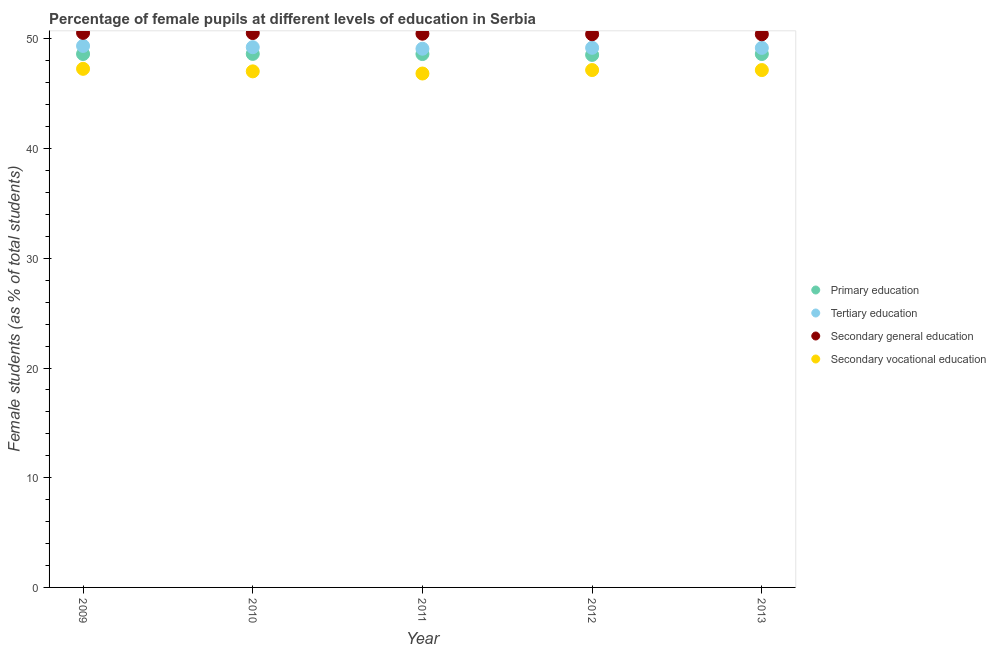Is the number of dotlines equal to the number of legend labels?
Your response must be concise. Yes. What is the percentage of female students in secondary education in 2013?
Make the answer very short. 50.43. Across all years, what is the maximum percentage of female students in tertiary education?
Provide a succinct answer. 49.36. Across all years, what is the minimum percentage of female students in secondary vocational education?
Give a very brief answer. 46.85. In which year was the percentage of female students in primary education maximum?
Ensure brevity in your answer.  2010. What is the total percentage of female students in tertiary education in the graph?
Make the answer very short. 246.1. What is the difference between the percentage of female students in tertiary education in 2009 and that in 2012?
Your answer should be compact. 0.17. What is the difference between the percentage of female students in tertiary education in 2011 and the percentage of female students in primary education in 2010?
Offer a terse response. 0.47. What is the average percentage of female students in secondary vocational education per year?
Offer a terse response. 47.1. In the year 2011, what is the difference between the percentage of female students in secondary vocational education and percentage of female students in secondary education?
Offer a terse response. -3.63. In how many years, is the percentage of female students in secondary education greater than 44 %?
Offer a very short reply. 5. What is the ratio of the percentage of female students in secondary vocational education in 2011 to that in 2013?
Provide a succinct answer. 0.99. Is the difference between the percentage of female students in primary education in 2010 and 2011 greater than the difference between the percentage of female students in secondary education in 2010 and 2011?
Give a very brief answer. No. What is the difference between the highest and the second highest percentage of female students in tertiary education?
Provide a short and direct response. 0.12. What is the difference between the highest and the lowest percentage of female students in secondary education?
Provide a succinct answer. 0.13. Is the sum of the percentage of female students in secondary vocational education in 2011 and 2012 greater than the maximum percentage of female students in secondary education across all years?
Make the answer very short. Yes. Is it the case that in every year, the sum of the percentage of female students in secondary education and percentage of female students in tertiary education is greater than the sum of percentage of female students in secondary vocational education and percentage of female students in primary education?
Give a very brief answer. No. Is it the case that in every year, the sum of the percentage of female students in primary education and percentage of female students in tertiary education is greater than the percentage of female students in secondary education?
Offer a very short reply. Yes. How many dotlines are there?
Your answer should be very brief. 4. How many years are there in the graph?
Your answer should be very brief. 5. What is the difference between two consecutive major ticks on the Y-axis?
Your answer should be compact. 10. Does the graph contain grids?
Provide a succinct answer. No. Where does the legend appear in the graph?
Make the answer very short. Center right. How many legend labels are there?
Your answer should be very brief. 4. What is the title of the graph?
Keep it short and to the point. Percentage of female pupils at different levels of education in Serbia. Does "Korea" appear as one of the legend labels in the graph?
Your response must be concise. No. What is the label or title of the Y-axis?
Provide a short and direct response. Female students (as % of total students). What is the Female students (as % of total students) of Primary education in 2009?
Give a very brief answer. 48.63. What is the Female students (as % of total students) in Tertiary education in 2009?
Keep it short and to the point. 49.36. What is the Female students (as % of total students) in Secondary general education in 2009?
Your answer should be compact. 50.56. What is the Female students (as % of total students) of Secondary vocational education in 2009?
Offer a very short reply. 47.28. What is the Female students (as % of total students) of Primary education in 2010?
Provide a succinct answer. 48.64. What is the Female students (as % of total students) in Tertiary education in 2010?
Keep it short and to the point. 49.25. What is the Female students (as % of total students) in Secondary general education in 2010?
Make the answer very short. 50.54. What is the Female students (as % of total students) in Secondary vocational education in 2010?
Provide a succinct answer. 47.05. What is the Female students (as % of total students) in Primary education in 2011?
Make the answer very short. 48.62. What is the Female students (as % of total students) in Tertiary education in 2011?
Your answer should be very brief. 49.11. What is the Female students (as % of total students) of Secondary general education in 2011?
Your response must be concise. 50.48. What is the Female students (as % of total students) in Secondary vocational education in 2011?
Keep it short and to the point. 46.85. What is the Female students (as % of total students) in Primary education in 2012?
Offer a terse response. 48.55. What is the Female students (as % of total students) in Tertiary education in 2012?
Give a very brief answer. 49.19. What is the Female students (as % of total students) of Secondary general education in 2012?
Make the answer very short. 50.43. What is the Female students (as % of total students) of Secondary vocational education in 2012?
Keep it short and to the point. 47.17. What is the Female students (as % of total students) of Primary education in 2013?
Make the answer very short. 48.63. What is the Female students (as % of total students) of Tertiary education in 2013?
Offer a very short reply. 49.18. What is the Female students (as % of total students) of Secondary general education in 2013?
Provide a short and direct response. 50.43. What is the Female students (as % of total students) of Secondary vocational education in 2013?
Provide a short and direct response. 47.16. Across all years, what is the maximum Female students (as % of total students) of Primary education?
Your response must be concise. 48.64. Across all years, what is the maximum Female students (as % of total students) in Tertiary education?
Provide a short and direct response. 49.36. Across all years, what is the maximum Female students (as % of total students) in Secondary general education?
Provide a succinct answer. 50.56. Across all years, what is the maximum Female students (as % of total students) in Secondary vocational education?
Your answer should be very brief. 47.28. Across all years, what is the minimum Female students (as % of total students) of Primary education?
Your answer should be very brief. 48.55. Across all years, what is the minimum Female students (as % of total students) of Tertiary education?
Your answer should be very brief. 49.11. Across all years, what is the minimum Female students (as % of total students) of Secondary general education?
Ensure brevity in your answer.  50.43. Across all years, what is the minimum Female students (as % of total students) in Secondary vocational education?
Your answer should be very brief. 46.85. What is the total Female students (as % of total students) in Primary education in the graph?
Offer a terse response. 243.06. What is the total Female students (as % of total students) of Tertiary education in the graph?
Make the answer very short. 246.1. What is the total Female students (as % of total students) of Secondary general education in the graph?
Your answer should be very brief. 252.43. What is the total Female students (as % of total students) of Secondary vocational education in the graph?
Offer a very short reply. 235.5. What is the difference between the Female students (as % of total students) in Primary education in 2009 and that in 2010?
Provide a succinct answer. -0.01. What is the difference between the Female students (as % of total students) of Tertiary education in 2009 and that in 2010?
Ensure brevity in your answer.  0.12. What is the difference between the Female students (as % of total students) in Secondary general education in 2009 and that in 2010?
Keep it short and to the point. 0.02. What is the difference between the Female students (as % of total students) in Secondary vocational education in 2009 and that in 2010?
Your answer should be compact. 0.23. What is the difference between the Female students (as % of total students) of Primary education in 2009 and that in 2011?
Offer a terse response. 0.01. What is the difference between the Female students (as % of total students) in Tertiary education in 2009 and that in 2011?
Ensure brevity in your answer.  0.26. What is the difference between the Female students (as % of total students) of Secondary general education in 2009 and that in 2011?
Make the answer very short. 0.08. What is the difference between the Female students (as % of total students) in Secondary vocational education in 2009 and that in 2011?
Your response must be concise. 0.43. What is the difference between the Female students (as % of total students) of Primary education in 2009 and that in 2012?
Your response must be concise. 0.08. What is the difference between the Female students (as % of total students) in Tertiary education in 2009 and that in 2012?
Offer a very short reply. 0.17. What is the difference between the Female students (as % of total students) of Secondary general education in 2009 and that in 2012?
Your response must be concise. 0.12. What is the difference between the Female students (as % of total students) in Secondary vocational education in 2009 and that in 2012?
Offer a terse response. 0.11. What is the difference between the Female students (as % of total students) in Primary education in 2009 and that in 2013?
Make the answer very short. 0. What is the difference between the Female students (as % of total students) of Tertiary education in 2009 and that in 2013?
Provide a short and direct response. 0.18. What is the difference between the Female students (as % of total students) in Secondary general education in 2009 and that in 2013?
Your answer should be compact. 0.13. What is the difference between the Female students (as % of total students) in Secondary vocational education in 2009 and that in 2013?
Offer a very short reply. 0.11. What is the difference between the Female students (as % of total students) in Primary education in 2010 and that in 2011?
Your answer should be very brief. 0.01. What is the difference between the Female students (as % of total students) in Tertiary education in 2010 and that in 2011?
Your answer should be compact. 0.14. What is the difference between the Female students (as % of total students) in Secondary general education in 2010 and that in 2011?
Provide a succinct answer. 0.06. What is the difference between the Female students (as % of total students) of Secondary vocational education in 2010 and that in 2011?
Offer a very short reply. 0.2. What is the difference between the Female students (as % of total students) of Primary education in 2010 and that in 2012?
Your response must be concise. 0.09. What is the difference between the Female students (as % of total students) in Tertiary education in 2010 and that in 2012?
Provide a succinct answer. 0.06. What is the difference between the Female students (as % of total students) of Secondary general education in 2010 and that in 2012?
Make the answer very short. 0.11. What is the difference between the Female students (as % of total students) in Secondary vocational education in 2010 and that in 2012?
Keep it short and to the point. -0.12. What is the difference between the Female students (as % of total students) of Primary education in 2010 and that in 2013?
Ensure brevity in your answer.  0.01. What is the difference between the Female students (as % of total students) in Tertiary education in 2010 and that in 2013?
Provide a short and direct response. 0.06. What is the difference between the Female students (as % of total students) of Secondary general education in 2010 and that in 2013?
Your response must be concise. 0.11. What is the difference between the Female students (as % of total students) in Secondary vocational education in 2010 and that in 2013?
Your answer should be very brief. -0.12. What is the difference between the Female students (as % of total students) in Primary education in 2011 and that in 2012?
Provide a short and direct response. 0.08. What is the difference between the Female students (as % of total students) of Tertiary education in 2011 and that in 2012?
Your answer should be compact. -0.08. What is the difference between the Female students (as % of total students) in Secondary general education in 2011 and that in 2012?
Provide a short and direct response. 0.05. What is the difference between the Female students (as % of total students) in Secondary vocational education in 2011 and that in 2012?
Your response must be concise. -0.32. What is the difference between the Female students (as % of total students) of Primary education in 2011 and that in 2013?
Ensure brevity in your answer.  -0. What is the difference between the Female students (as % of total students) of Tertiary education in 2011 and that in 2013?
Offer a terse response. -0.08. What is the difference between the Female students (as % of total students) in Secondary general education in 2011 and that in 2013?
Offer a terse response. 0.05. What is the difference between the Female students (as % of total students) of Secondary vocational education in 2011 and that in 2013?
Make the answer very short. -0.31. What is the difference between the Female students (as % of total students) of Primary education in 2012 and that in 2013?
Offer a terse response. -0.08. What is the difference between the Female students (as % of total students) of Tertiary education in 2012 and that in 2013?
Make the answer very short. 0.01. What is the difference between the Female students (as % of total students) of Secondary general education in 2012 and that in 2013?
Ensure brevity in your answer.  0. What is the difference between the Female students (as % of total students) of Secondary vocational education in 2012 and that in 2013?
Your answer should be compact. 0. What is the difference between the Female students (as % of total students) in Primary education in 2009 and the Female students (as % of total students) in Tertiary education in 2010?
Keep it short and to the point. -0.62. What is the difference between the Female students (as % of total students) of Primary education in 2009 and the Female students (as % of total students) of Secondary general education in 2010?
Your answer should be compact. -1.91. What is the difference between the Female students (as % of total students) of Primary education in 2009 and the Female students (as % of total students) of Secondary vocational education in 2010?
Keep it short and to the point. 1.58. What is the difference between the Female students (as % of total students) of Tertiary education in 2009 and the Female students (as % of total students) of Secondary general education in 2010?
Make the answer very short. -1.17. What is the difference between the Female students (as % of total students) in Tertiary education in 2009 and the Female students (as % of total students) in Secondary vocational education in 2010?
Your answer should be very brief. 2.32. What is the difference between the Female students (as % of total students) in Secondary general education in 2009 and the Female students (as % of total students) in Secondary vocational education in 2010?
Give a very brief answer. 3.51. What is the difference between the Female students (as % of total students) of Primary education in 2009 and the Female students (as % of total students) of Tertiary education in 2011?
Keep it short and to the point. -0.48. What is the difference between the Female students (as % of total students) in Primary education in 2009 and the Female students (as % of total students) in Secondary general education in 2011?
Give a very brief answer. -1.85. What is the difference between the Female students (as % of total students) of Primary education in 2009 and the Female students (as % of total students) of Secondary vocational education in 2011?
Your response must be concise. 1.78. What is the difference between the Female students (as % of total students) of Tertiary education in 2009 and the Female students (as % of total students) of Secondary general education in 2011?
Your answer should be very brief. -1.12. What is the difference between the Female students (as % of total students) of Tertiary education in 2009 and the Female students (as % of total students) of Secondary vocational education in 2011?
Give a very brief answer. 2.51. What is the difference between the Female students (as % of total students) in Secondary general education in 2009 and the Female students (as % of total students) in Secondary vocational education in 2011?
Provide a short and direct response. 3.71. What is the difference between the Female students (as % of total students) of Primary education in 2009 and the Female students (as % of total students) of Tertiary education in 2012?
Make the answer very short. -0.56. What is the difference between the Female students (as % of total students) of Primary education in 2009 and the Female students (as % of total students) of Secondary general education in 2012?
Make the answer very short. -1.8. What is the difference between the Female students (as % of total students) of Primary education in 2009 and the Female students (as % of total students) of Secondary vocational education in 2012?
Make the answer very short. 1.46. What is the difference between the Female students (as % of total students) in Tertiary education in 2009 and the Female students (as % of total students) in Secondary general education in 2012?
Provide a succinct answer. -1.07. What is the difference between the Female students (as % of total students) of Tertiary education in 2009 and the Female students (as % of total students) of Secondary vocational education in 2012?
Offer a terse response. 2.2. What is the difference between the Female students (as % of total students) in Secondary general education in 2009 and the Female students (as % of total students) in Secondary vocational education in 2012?
Keep it short and to the point. 3.39. What is the difference between the Female students (as % of total students) of Primary education in 2009 and the Female students (as % of total students) of Tertiary education in 2013?
Make the answer very short. -0.56. What is the difference between the Female students (as % of total students) of Primary education in 2009 and the Female students (as % of total students) of Secondary general education in 2013?
Give a very brief answer. -1.8. What is the difference between the Female students (as % of total students) of Primary education in 2009 and the Female students (as % of total students) of Secondary vocational education in 2013?
Provide a succinct answer. 1.47. What is the difference between the Female students (as % of total students) of Tertiary education in 2009 and the Female students (as % of total students) of Secondary general education in 2013?
Provide a succinct answer. -1.06. What is the difference between the Female students (as % of total students) in Tertiary education in 2009 and the Female students (as % of total students) in Secondary vocational education in 2013?
Your response must be concise. 2.2. What is the difference between the Female students (as % of total students) in Secondary general education in 2009 and the Female students (as % of total students) in Secondary vocational education in 2013?
Give a very brief answer. 3.39. What is the difference between the Female students (as % of total students) in Primary education in 2010 and the Female students (as % of total students) in Tertiary education in 2011?
Provide a short and direct response. -0.47. What is the difference between the Female students (as % of total students) of Primary education in 2010 and the Female students (as % of total students) of Secondary general education in 2011?
Your response must be concise. -1.84. What is the difference between the Female students (as % of total students) in Primary education in 2010 and the Female students (as % of total students) in Secondary vocational education in 2011?
Your response must be concise. 1.79. What is the difference between the Female students (as % of total students) in Tertiary education in 2010 and the Female students (as % of total students) in Secondary general education in 2011?
Your answer should be compact. -1.23. What is the difference between the Female students (as % of total students) of Tertiary education in 2010 and the Female students (as % of total students) of Secondary vocational education in 2011?
Offer a terse response. 2.4. What is the difference between the Female students (as % of total students) of Secondary general education in 2010 and the Female students (as % of total students) of Secondary vocational education in 2011?
Give a very brief answer. 3.69. What is the difference between the Female students (as % of total students) of Primary education in 2010 and the Female students (as % of total students) of Tertiary education in 2012?
Your response must be concise. -0.55. What is the difference between the Female students (as % of total students) in Primary education in 2010 and the Female students (as % of total students) in Secondary general education in 2012?
Your answer should be compact. -1.79. What is the difference between the Female students (as % of total students) in Primary education in 2010 and the Female students (as % of total students) in Secondary vocational education in 2012?
Keep it short and to the point. 1.47. What is the difference between the Female students (as % of total students) in Tertiary education in 2010 and the Female students (as % of total students) in Secondary general education in 2012?
Offer a very short reply. -1.18. What is the difference between the Female students (as % of total students) in Tertiary education in 2010 and the Female students (as % of total students) in Secondary vocational education in 2012?
Your answer should be compact. 2.08. What is the difference between the Female students (as % of total students) in Secondary general education in 2010 and the Female students (as % of total students) in Secondary vocational education in 2012?
Ensure brevity in your answer.  3.37. What is the difference between the Female students (as % of total students) in Primary education in 2010 and the Female students (as % of total students) in Tertiary education in 2013?
Your answer should be very brief. -0.55. What is the difference between the Female students (as % of total students) in Primary education in 2010 and the Female students (as % of total students) in Secondary general education in 2013?
Your answer should be compact. -1.79. What is the difference between the Female students (as % of total students) of Primary education in 2010 and the Female students (as % of total students) of Secondary vocational education in 2013?
Offer a very short reply. 1.47. What is the difference between the Female students (as % of total students) of Tertiary education in 2010 and the Female students (as % of total students) of Secondary general education in 2013?
Offer a very short reply. -1.18. What is the difference between the Female students (as % of total students) of Tertiary education in 2010 and the Female students (as % of total students) of Secondary vocational education in 2013?
Offer a very short reply. 2.08. What is the difference between the Female students (as % of total students) in Secondary general education in 2010 and the Female students (as % of total students) in Secondary vocational education in 2013?
Offer a very short reply. 3.38. What is the difference between the Female students (as % of total students) in Primary education in 2011 and the Female students (as % of total students) in Tertiary education in 2012?
Give a very brief answer. -0.57. What is the difference between the Female students (as % of total students) in Primary education in 2011 and the Female students (as % of total students) in Secondary general education in 2012?
Keep it short and to the point. -1.81. What is the difference between the Female students (as % of total students) of Primary education in 2011 and the Female students (as % of total students) of Secondary vocational education in 2012?
Offer a very short reply. 1.46. What is the difference between the Female students (as % of total students) in Tertiary education in 2011 and the Female students (as % of total students) in Secondary general education in 2012?
Give a very brief answer. -1.32. What is the difference between the Female students (as % of total students) in Tertiary education in 2011 and the Female students (as % of total students) in Secondary vocational education in 2012?
Offer a terse response. 1.94. What is the difference between the Female students (as % of total students) of Secondary general education in 2011 and the Female students (as % of total students) of Secondary vocational education in 2012?
Offer a terse response. 3.31. What is the difference between the Female students (as % of total students) of Primary education in 2011 and the Female students (as % of total students) of Tertiary education in 2013?
Your response must be concise. -0.56. What is the difference between the Female students (as % of total students) of Primary education in 2011 and the Female students (as % of total students) of Secondary general education in 2013?
Give a very brief answer. -1.8. What is the difference between the Female students (as % of total students) in Primary education in 2011 and the Female students (as % of total students) in Secondary vocational education in 2013?
Ensure brevity in your answer.  1.46. What is the difference between the Female students (as % of total students) in Tertiary education in 2011 and the Female students (as % of total students) in Secondary general education in 2013?
Give a very brief answer. -1.32. What is the difference between the Female students (as % of total students) of Tertiary education in 2011 and the Female students (as % of total students) of Secondary vocational education in 2013?
Your response must be concise. 1.95. What is the difference between the Female students (as % of total students) in Secondary general education in 2011 and the Female students (as % of total students) in Secondary vocational education in 2013?
Provide a succinct answer. 3.32. What is the difference between the Female students (as % of total students) of Primary education in 2012 and the Female students (as % of total students) of Tertiary education in 2013?
Provide a short and direct response. -0.64. What is the difference between the Female students (as % of total students) of Primary education in 2012 and the Female students (as % of total students) of Secondary general education in 2013?
Give a very brief answer. -1.88. What is the difference between the Female students (as % of total students) of Primary education in 2012 and the Female students (as % of total students) of Secondary vocational education in 2013?
Give a very brief answer. 1.38. What is the difference between the Female students (as % of total students) in Tertiary education in 2012 and the Female students (as % of total students) in Secondary general education in 2013?
Provide a short and direct response. -1.24. What is the difference between the Female students (as % of total students) of Tertiary education in 2012 and the Female students (as % of total students) of Secondary vocational education in 2013?
Your response must be concise. 2.03. What is the difference between the Female students (as % of total students) of Secondary general education in 2012 and the Female students (as % of total students) of Secondary vocational education in 2013?
Offer a terse response. 3.27. What is the average Female students (as % of total students) of Primary education per year?
Ensure brevity in your answer.  48.61. What is the average Female students (as % of total students) in Tertiary education per year?
Offer a very short reply. 49.22. What is the average Female students (as % of total students) in Secondary general education per year?
Give a very brief answer. 50.49. What is the average Female students (as % of total students) of Secondary vocational education per year?
Make the answer very short. 47.1. In the year 2009, what is the difference between the Female students (as % of total students) in Primary education and Female students (as % of total students) in Tertiary education?
Offer a terse response. -0.73. In the year 2009, what is the difference between the Female students (as % of total students) in Primary education and Female students (as % of total students) in Secondary general education?
Give a very brief answer. -1.93. In the year 2009, what is the difference between the Female students (as % of total students) in Primary education and Female students (as % of total students) in Secondary vocational education?
Offer a terse response. 1.35. In the year 2009, what is the difference between the Female students (as % of total students) of Tertiary education and Female students (as % of total students) of Secondary general education?
Your answer should be very brief. -1.19. In the year 2009, what is the difference between the Female students (as % of total students) of Tertiary education and Female students (as % of total students) of Secondary vocational education?
Make the answer very short. 2.09. In the year 2009, what is the difference between the Female students (as % of total students) of Secondary general education and Female students (as % of total students) of Secondary vocational education?
Keep it short and to the point. 3.28. In the year 2010, what is the difference between the Female students (as % of total students) of Primary education and Female students (as % of total students) of Tertiary education?
Make the answer very short. -0.61. In the year 2010, what is the difference between the Female students (as % of total students) in Primary education and Female students (as % of total students) in Secondary general education?
Your answer should be very brief. -1.9. In the year 2010, what is the difference between the Female students (as % of total students) of Primary education and Female students (as % of total students) of Secondary vocational education?
Offer a terse response. 1.59. In the year 2010, what is the difference between the Female students (as % of total students) of Tertiary education and Female students (as % of total students) of Secondary general education?
Provide a short and direct response. -1.29. In the year 2010, what is the difference between the Female students (as % of total students) of Tertiary education and Female students (as % of total students) of Secondary vocational education?
Keep it short and to the point. 2.2. In the year 2010, what is the difference between the Female students (as % of total students) of Secondary general education and Female students (as % of total students) of Secondary vocational education?
Ensure brevity in your answer.  3.49. In the year 2011, what is the difference between the Female students (as % of total students) of Primary education and Female students (as % of total students) of Tertiary education?
Keep it short and to the point. -0.48. In the year 2011, what is the difference between the Female students (as % of total students) of Primary education and Female students (as % of total students) of Secondary general education?
Ensure brevity in your answer.  -1.86. In the year 2011, what is the difference between the Female students (as % of total students) in Primary education and Female students (as % of total students) in Secondary vocational education?
Offer a very short reply. 1.77. In the year 2011, what is the difference between the Female students (as % of total students) of Tertiary education and Female students (as % of total students) of Secondary general education?
Provide a short and direct response. -1.37. In the year 2011, what is the difference between the Female students (as % of total students) in Tertiary education and Female students (as % of total students) in Secondary vocational education?
Give a very brief answer. 2.26. In the year 2011, what is the difference between the Female students (as % of total students) of Secondary general education and Female students (as % of total students) of Secondary vocational education?
Offer a terse response. 3.63. In the year 2012, what is the difference between the Female students (as % of total students) in Primary education and Female students (as % of total students) in Tertiary education?
Offer a very short reply. -0.65. In the year 2012, what is the difference between the Female students (as % of total students) of Primary education and Female students (as % of total students) of Secondary general education?
Make the answer very short. -1.89. In the year 2012, what is the difference between the Female students (as % of total students) in Primary education and Female students (as % of total students) in Secondary vocational education?
Provide a short and direct response. 1.38. In the year 2012, what is the difference between the Female students (as % of total students) in Tertiary education and Female students (as % of total students) in Secondary general education?
Offer a very short reply. -1.24. In the year 2012, what is the difference between the Female students (as % of total students) in Tertiary education and Female students (as % of total students) in Secondary vocational education?
Offer a terse response. 2.03. In the year 2012, what is the difference between the Female students (as % of total students) of Secondary general education and Female students (as % of total students) of Secondary vocational education?
Keep it short and to the point. 3.27. In the year 2013, what is the difference between the Female students (as % of total students) of Primary education and Female students (as % of total students) of Tertiary education?
Offer a terse response. -0.56. In the year 2013, what is the difference between the Female students (as % of total students) in Primary education and Female students (as % of total students) in Secondary general education?
Provide a succinct answer. -1.8. In the year 2013, what is the difference between the Female students (as % of total students) of Primary education and Female students (as % of total students) of Secondary vocational education?
Offer a terse response. 1.46. In the year 2013, what is the difference between the Female students (as % of total students) in Tertiary education and Female students (as % of total students) in Secondary general education?
Give a very brief answer. -1.24. In the year 2013, what is the difference between the Female students (as % of total students) in Tertiary education and Female students (as % of total students) in Secondary vocational education?
Your answer should be compact. 2.02. In the year 2013, what is the difference between the Female students (as % of total students) in Secondary general education and Female students (as % of total students) in Secondary vocational education?
Keep it short and to the point. 3.26. What is the ratio of the Female students (as % of total students) in Primary education in 2009 to that in 2010?
Provide a short and direct response. 1. What is the ratio of the Female students (as % of total students) in Secondary vocational education in 2009 to that in 2010?
Provide a succinct answer. 1. What is the ratio of the Female students (as % of total students) of Primary education in 2009 to that in 2011?
Provide a succinct answer. 1. What is the ratio of the Female students (as % of total students) of Tertiary education in 2009 to that in 2011?
Keep it short and to the point. 1.01. What is the ratio of the Female students (as % of total students) in Secondary vocational education in 2009 to that in 2011?
Keep it short and to the point. 1.01. What is the ratio of the Female students (as % of total students) in Secondary vocational education in 2009 to that in 2012?
Keep it short and to the point. 1. What is the ratio of the Female students (as % of total students) in Tertiary education in 2009 to that in 2013?
Make the answer very short. 1. What is the ratio of the Female students (as % of total students) of Secondary vocational education in 2009 to that in 2013?
Your answer should be compact. 1. What is the ratio of the Female students (as % of total students) in Tertiary education in 2010 to that in 2011?
Provide a short and direct response. 1. What is the ratio of the Female students (as % of total students) in Secondary general education in 2010 to that in 2011?
Offer a terse response. 1. What is the ratio of the Female students (as % of total students) of Primary education in 2010 to that in 2012?
Your response must be concise. 1. What is the ratio of the Female students (as % of total students) in Secondary vocational education in 2010 to that in 2012?
Ensure brevity in your answer.  1. What is the ratio of the Female students (as % of total students) in Primary education in 2010 to that in 2013?
Make the answer very short. 1. What is the ratio of the Female students (as % of total students) in Secondary general education in 2010 to that in 2013?
Your answer should be very brief. 1. What is the ratio of the Female students (as % of total students) of Tertiary education in 2011 to that in 2012?
Keep it short and to the point. 1. What is the ratio of the Female students (as % of total students) of Secondary vocational education in 2011 to that in 2012?
Keep it short and to the point. 0.99. What is the ratio of the Female students (as % of total students) in Tertiary education in 2011 to that in 2013?
Provide a succinct answer. 1. What is the ratio of the Female students (as % of total students) of Secondary vocational education in 2011 to that in 2013?
Ensure brevity in your answer.  0.99. What is the ratio of the Female students (as % of total students) of Secondary general education in 2012 to that in 2013?
Make the answer very short. 1. What is the difference between the highest and the second highest Female students (as % of total students) of Primary education?
Give a very brief answer. 0.01. What is the difference between the highest and the second highest Female students (as % of total students) in Tertiary education?
Your answer should be very brief. 0.12. What is the difference between the highest and the second highest Female students (as % of total students) in Secondary general education?
Make the answer very short. 0.02. What is the difference between the highest and the second highest Female students (as % of total students) in Secondary vocational education?
Give a very brief answer. 0.11. What is the difference between the highest and the lowest Female students (as % of total students) in Primary education?
Make the answer very short. 0.09. What is the difference between the highest and the lowest Female students (as % of total students) of Tertiary education?
Provide a succinct answer. 0.26. What is the difference between the highest and the lowest Female students (as % of total students) in Secondary general education?
Provide a short and direct response. 0.13. What is the difference between the highest and the lowest Female students (as % of total students) of Secondary vocational education?
Provide a succinct answer. 0.43. 